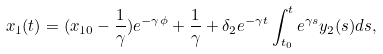<formula> <loc_0><loc_0><loc_500><loc_500>x _ { 1 } ( t ) = ( x _ { 1 0 } - \frac { 1 } { \gamma } ) e ^ { - \gamma \phi } + \frac { 1 } { \gamma } + \delta _ { 2 } e ^ { - \gamma t } \int _ { t _ { 0 } } ^ { t } e ^ { \gamma s } y _ { 2 } ( s ) d s ,</formula> 